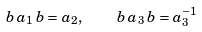<formula> <loc_0><loc_0><loc_500><loc_500>b \, a _ { 1 } \, b = a _ { 2 } , \quad b \, a _ { 3 } \, b = a _ { 3 } ^ { - 1 }</formula> 